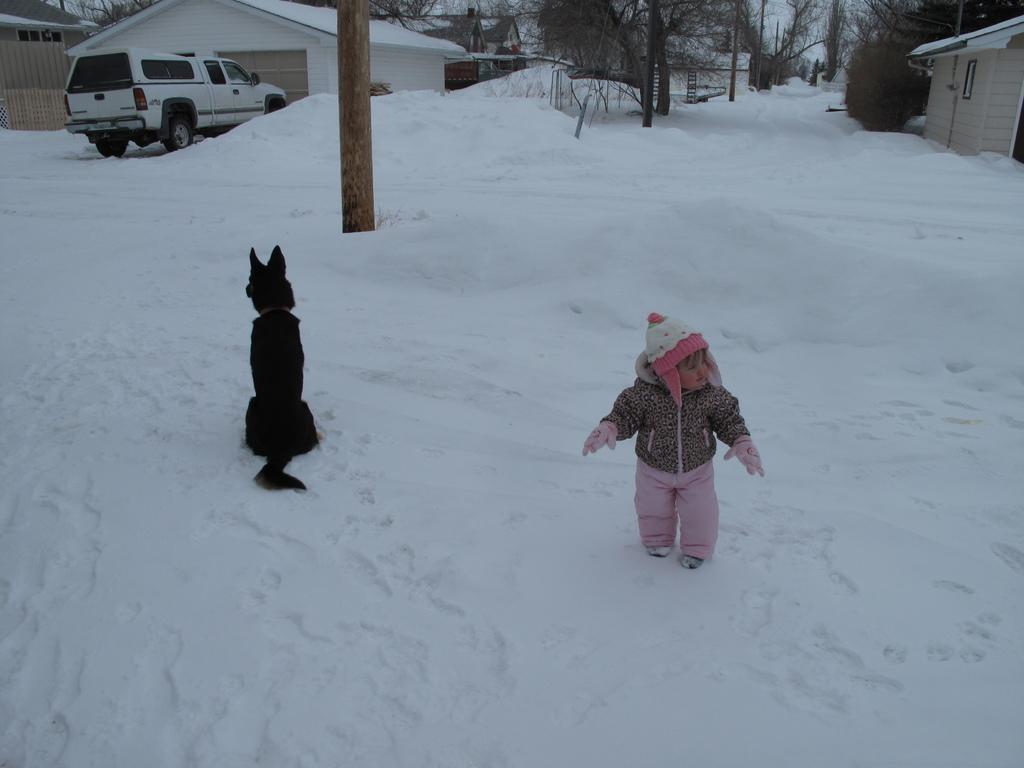What type of animal is in the image? There is a dog in the image. Who else is present in the image? There is a kid in the image. What is the condition of the ground in the image? The ground in the image is snowy. What mode of transportation can be seen in the image? There is a vehicle in the image. What type of natural scenery is visible in the image? There are trees in the image. What type of man-made structures are visible in the image? There are houses in the image. What type of poison is being used by the dog in the image? There is no poison present in the image; the dog is not using any poison. What force is being applied by the kid to the vehicle in the image? The kid is not applying any force to the vehicle in the image; they are simply standing near it. 